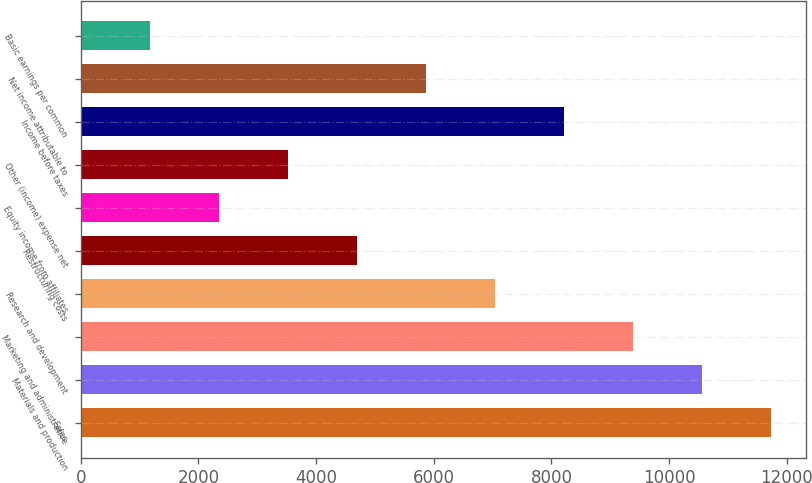<chart> <loc_0><loc_0><loc_500><loc_500><bar_chart><fcel>Sales<fcel>Materials and production<fcel>Marketing and administrative<fcel>Research and development<fcel>Restructuring costs<fcel>Equity income from affiliates<fcel>Other (income) expense net<fcel>Income before taxes<fcel>Net income attributable to<fcel>Basic earnings per common<nl><fcel>11731<fcel>10557.9<fcel>9384.88<fcel>7038.8<fcel>4692.72<fcel>2346.64<fcel>3519.68<fcel>8211.84<fcel>5865.76<fcel>1173.6<nl></chart> 